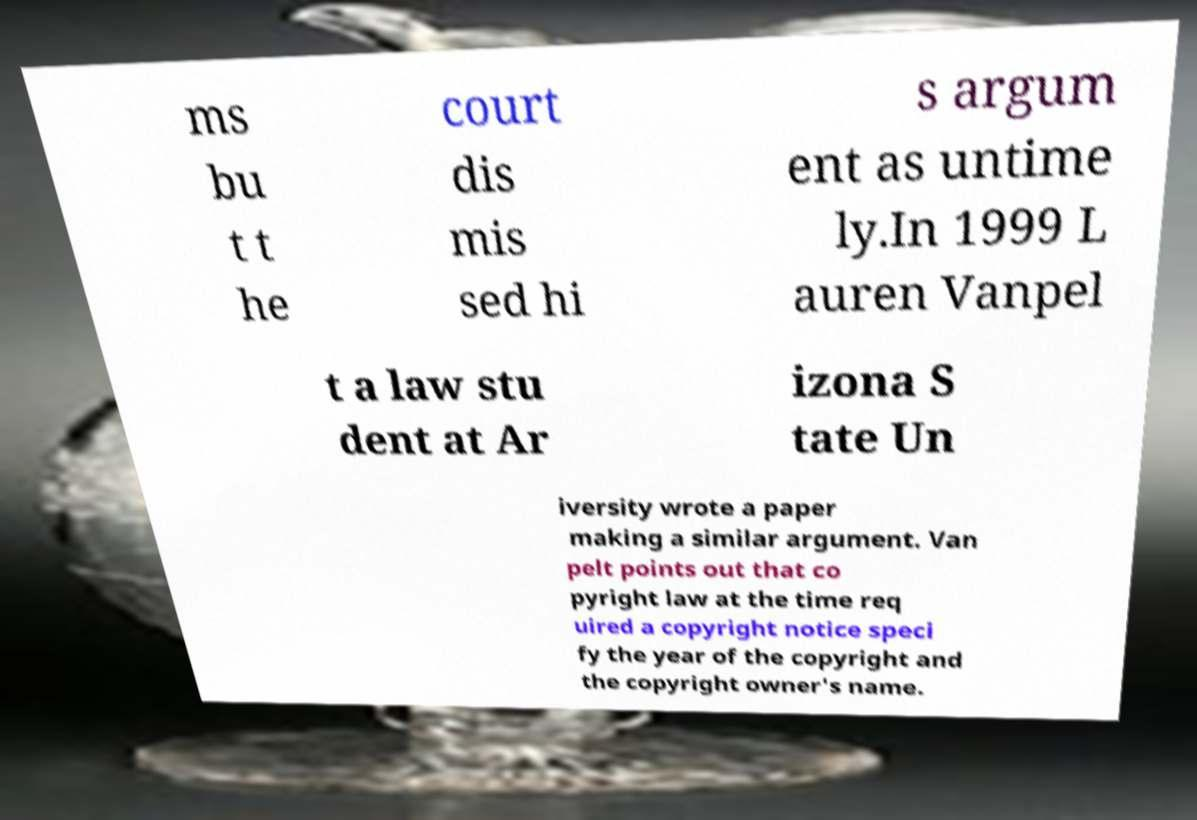Could you assist in decoding the text presented in this image and type it out clearly? ms bu t t he court dis mis sed hi s argum ent as untime ly.In 1999 L auren Vanpel t a law stu dent at Ar izona S tate Un iversity wrote a paper making a similar argument. Van pelt points out that co pyright law at the time req uired a copyright notice speci fy the year of the copyright and the copyright owner's name. 